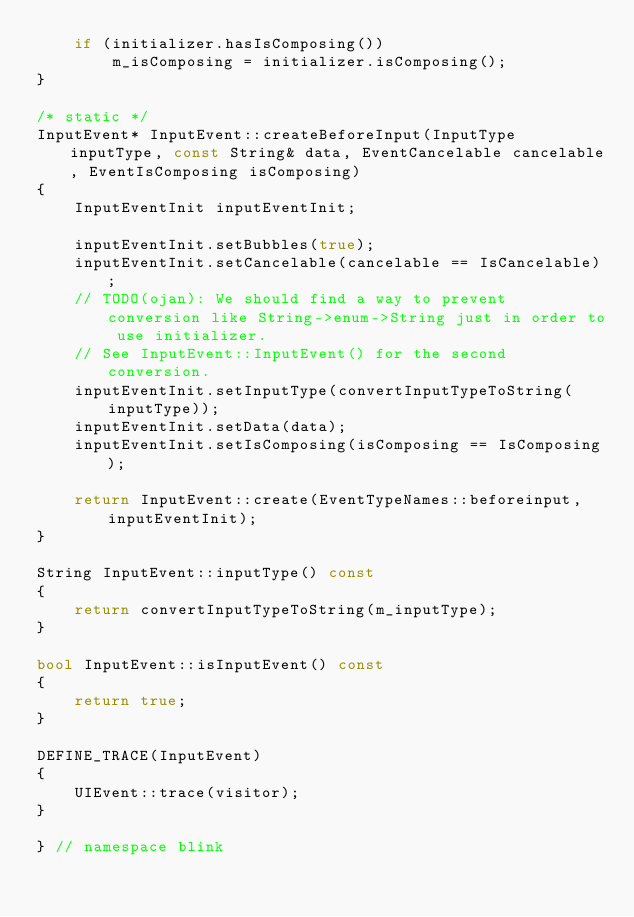Convert code to text. <code><loc_0><loc_0><loc_500><loc_500><_C++_>    if (initializer.hasIsComposing())
        m_isComposing = initializer.isComposing();
}

/* static */
InputEvent* InputEvent::createBeforeInput(InputType inputType, const String& data, EventCancelable cancelable, EventIsComposing isComposing)
{
    InputEventInit inputEventInit;

    inputEventInit.setBubbles(true);
    inputEventInit.setCancelable(cancelable == IsCancelable);
    // TODO(ojan): We should find a way to prevent conversion like String->enum->String just in order to use initializer.
    // See InputEvent::InputEvent() for the second conversion.
    inputEventInit.setInputType(convertInputTypeToString(inputType));
    inputEventInit.setData(data);
    inputEventInit.setIsComposing(isComposing == IsComposing);

    return InputEvent::create(EventTypeNames::beforeinput, inputEventInit);
}

String InputEvent::inputType() const
{
    return convertInputTypeToString(m_inputType);
}

bool InputEvent::isInputEvent() const
{
    return true;
}

DEFINE_TRACE(InputEvent)
{
    UIEvent::trace(visitor);
}

} // namespace blink
</code> 